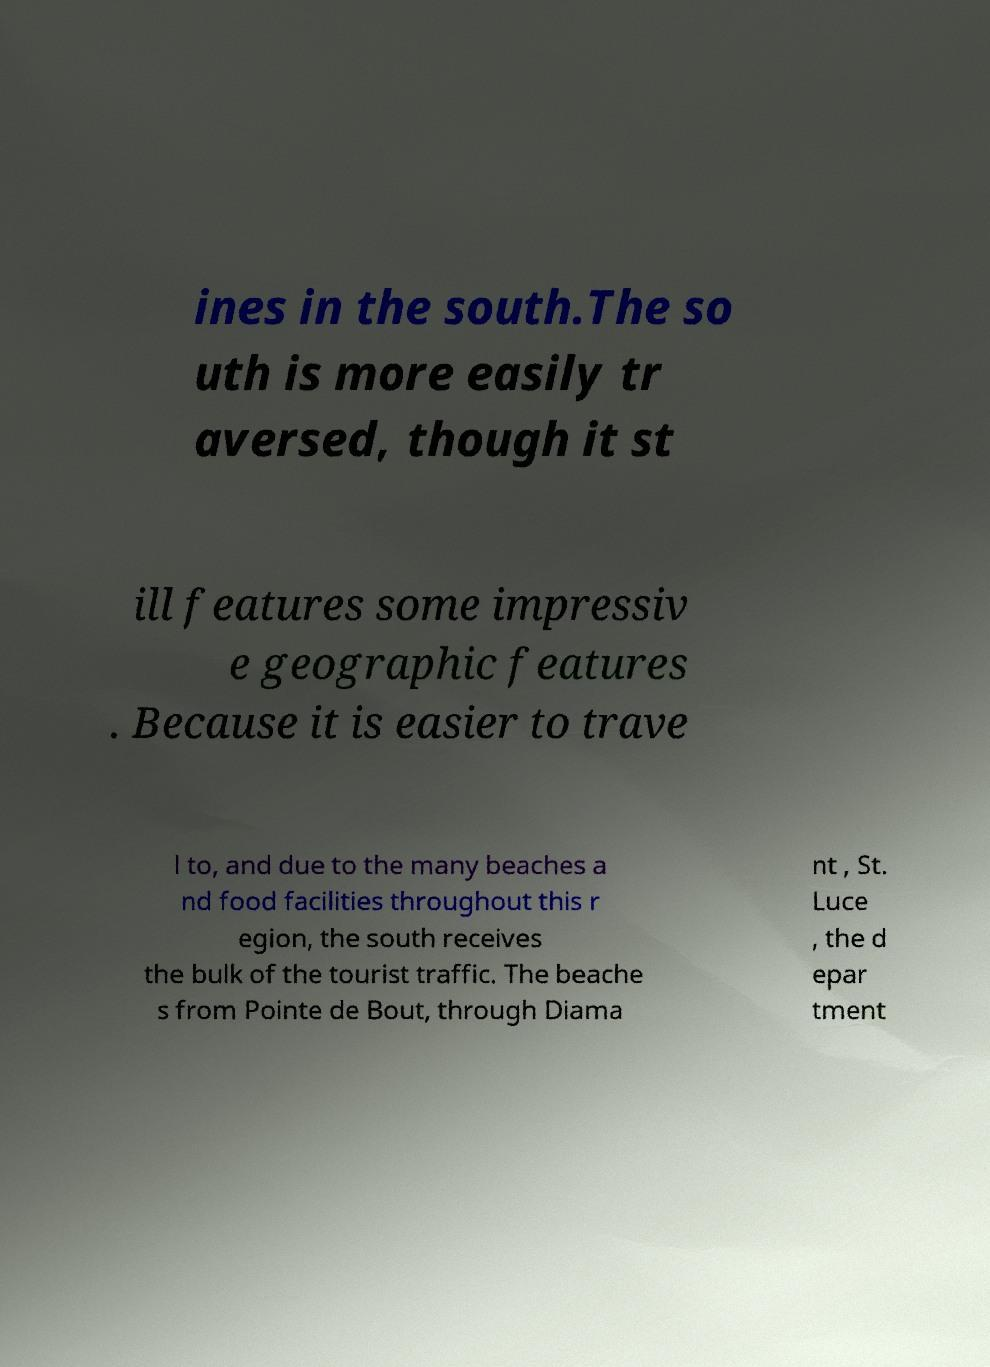Please read and relay the text visible in this image. What does it say? ines in the south.The so uth is more easily tr aversed, though it st ill features some impressiv e geographic features . Because it is easier to trave l to, and due to the many beaches a nd food facilities throughout this r egion, the south receives the bulk of the tourist traffic. The beache s from Pointe de Bout, through Diama nt , St. Luce , the d epar tment 